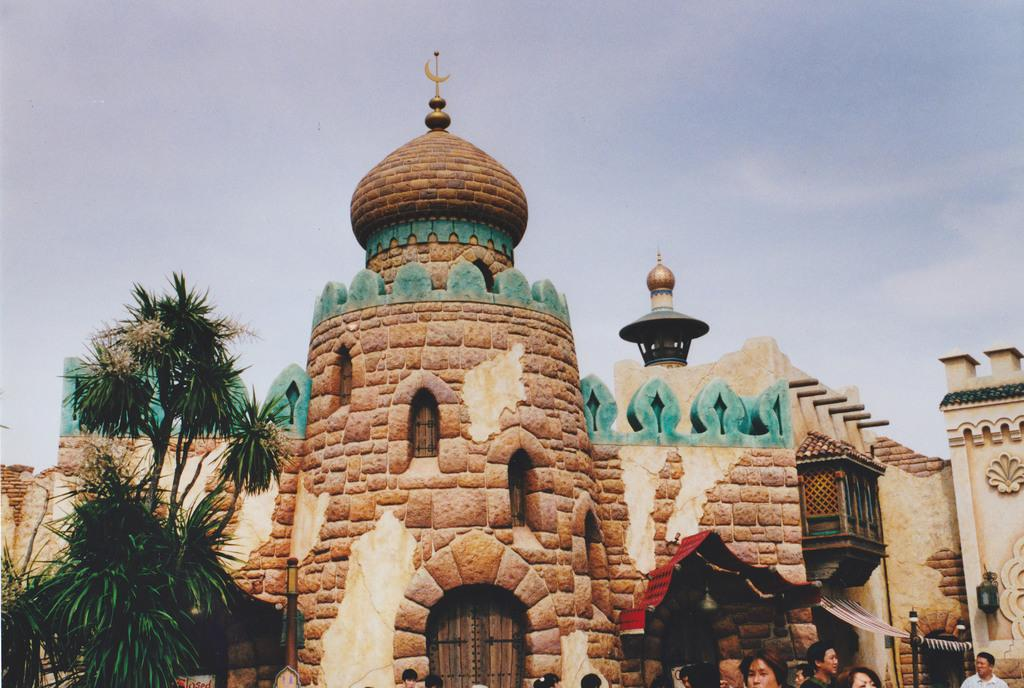What is the main structure in the middle of the image? There is a castle in the middle of the image. What type of vegetation is on the left side of the image? There are trees on the left side of the image. What is visible at the top of the image? The sky is visible at the top of the image. What is the condition of the horses in the image? There are no horses present in the image. What is the fifth element in the image? The provided facts only mention three elements (castle, trees, and sky), so there is no fifth element to discuss. 